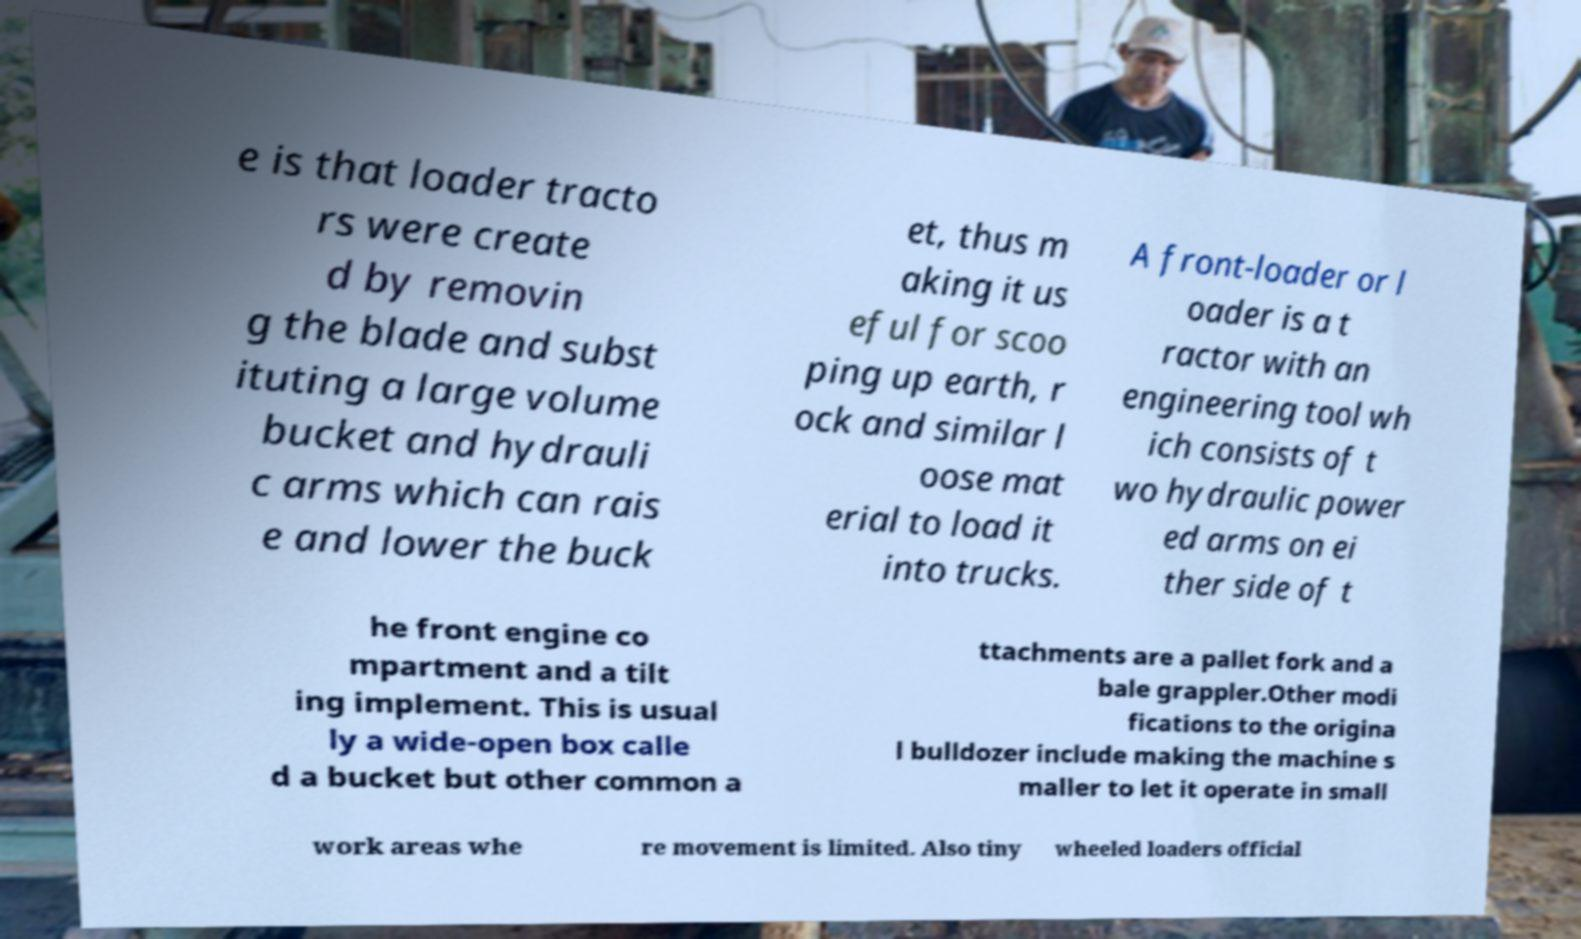Could you assist in decoding the text presented in this image and type it out clearly? e is that loader tracto rs were create d by removin g the blade and subst ituting a large volume bucket and hydrauli c arms which can rais e and lower the buck et, thus m aking it us eful for scoo ping up earth, r ock and similar l oose mat erial to load it into trucks. A front-loader or l oader is a t ractor with an engineering tool wh ich consists of t wo hydraulic power ed arms on ei ther side of t he front engine co mpartment and a tilt ing implement. This is usual ly a wide-open box calle d a bucket but other common a ttachments are a pallet fork and a bale grappler.Other modi fications to the origina l bulldozer include making the machine s maller to let it operate in small work areas whe re movement is limited. Also tiny wheeled loaders official 